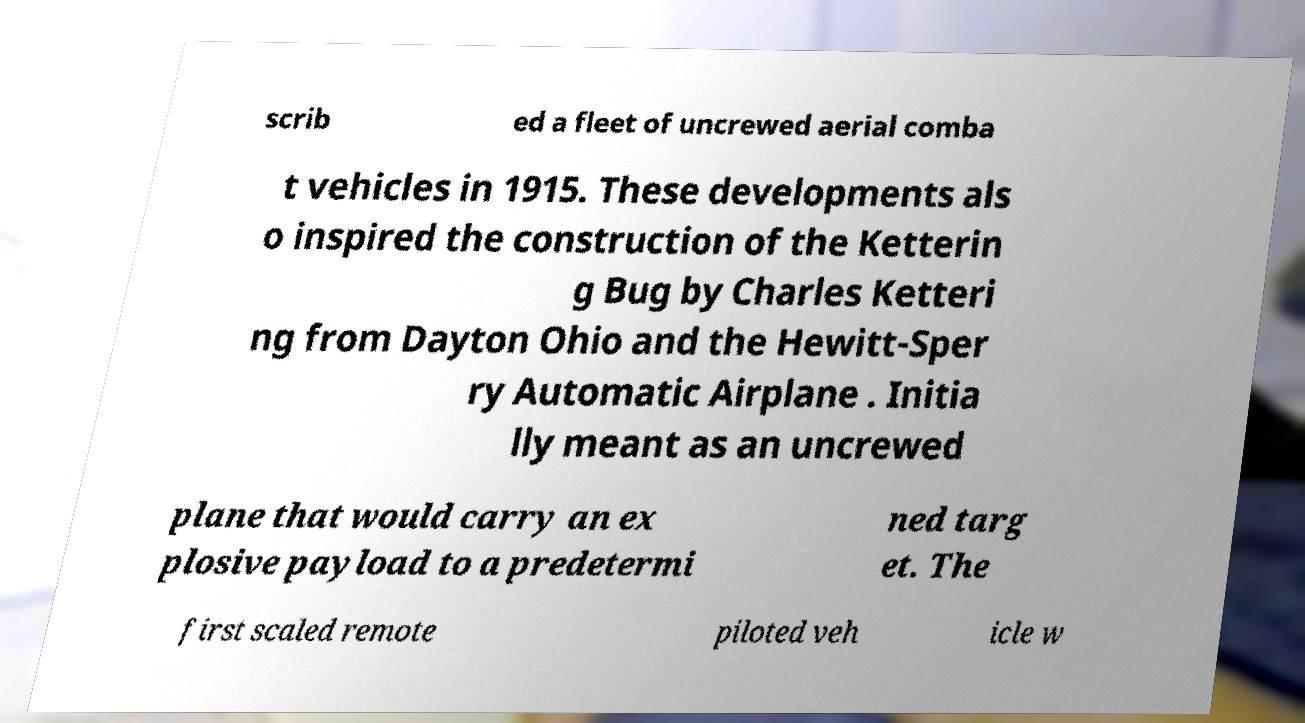Can you accurately transcribe the text from the provided image for me? scrib ed a fleet of uncrewed aerial comba t vehicles in 1915. These developments als o inspired the construction of the Ketterin g Bug by Charles Ketteri ng from Dayton Ohio and the Hewitt-Sper ry Automatic Airplane . Initia lly meant as an uncrewed plane that would carry an ex plosive payload to a predetermi ned targ et. The first scaled remote piloted veh icle w 